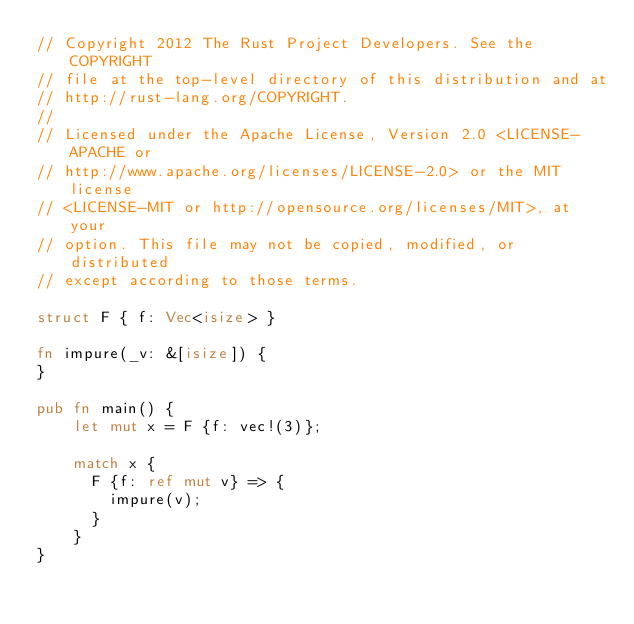<code> <loc_0><loc_0><loc_500><loc_500><_Rust_>// Copyright 2012 The Rust Project Developers. See the COPYRIGHT
// file at the top-level directory of this distribution and at
// http://rust-lang.org/COPYRIGHT.
//
// Licensed under the Apache License, Version 2.0 <LICENSE-APACHE or
// http://www.apache.org/licenses/LICENSE-2.0> or the MIT license
// <LICENSE-MIT or http://opensource.org/licenses/MIT>, at your
// option. This file may not be copied, modified, or distributed
// except according to those terms.

struct F { f: Vec<isize> }

fn impure(_v: &[isize]) {
}

pub fn main() {
    let mut x = F {f: vec!(3)};

    match x {
      F {f: ref mut v} => {
        impure(v);
      }
    }
}
</code> 